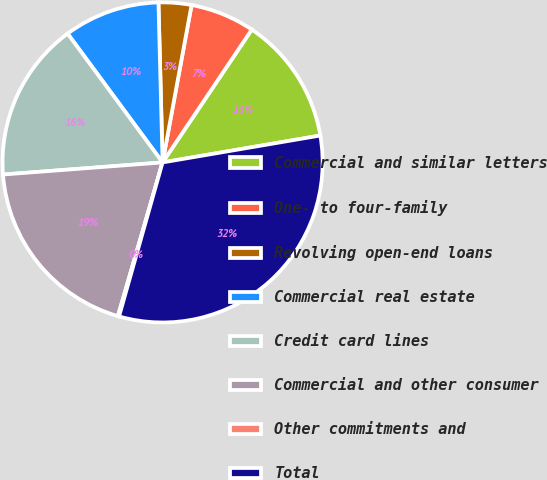Convert chart to OTSL. <chart><loc_0><loc_0><loc_500><loc_500><pie_chart><fcel>Commercial and similar letters<fcel>One- to four-family<fcel>Revolving open-end loans<fcel>Commercial real estate<fcel>Credit card lines<fcel>Commercial and other consumer<fcel>Other commitments and<fcel>Total<nl><fcel>12.9%<fcel>6.51%<fcel>3.31%<fcel>9.7%<fcel>16.09%<fcel>19.29%<fcel>0.12%<fcel>32.07%<nl></chart> 